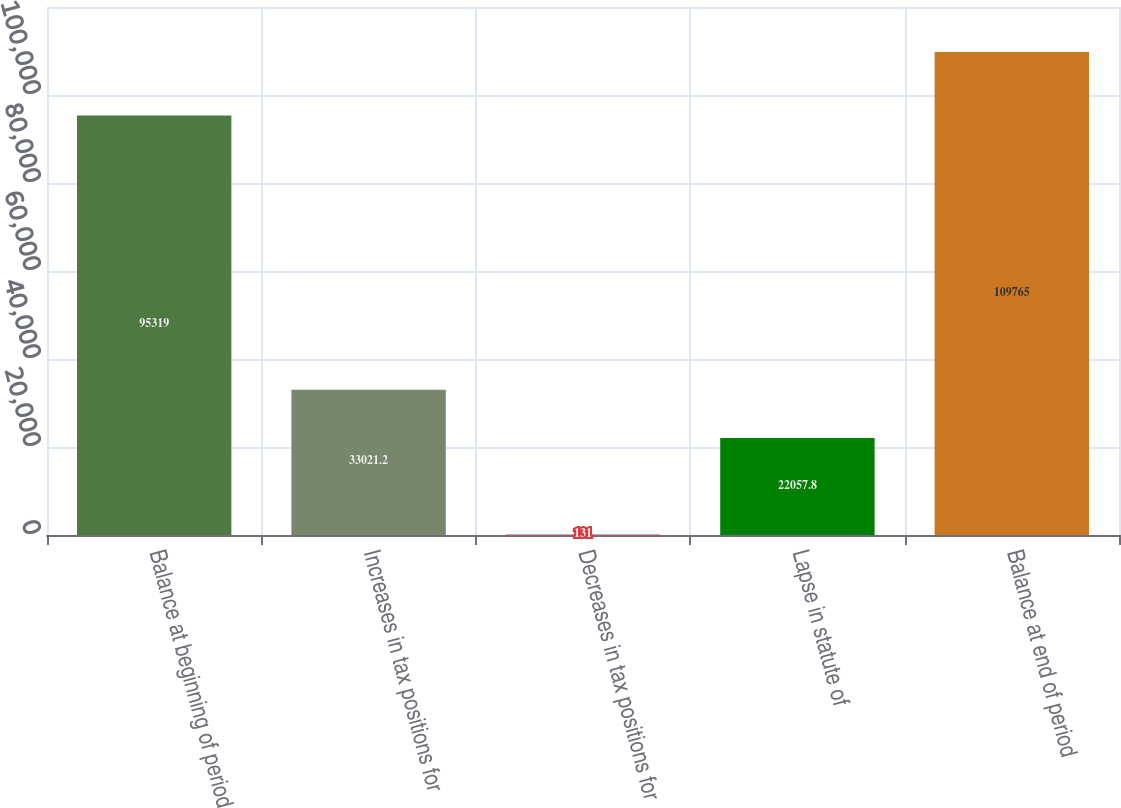Convert chart to OTSL. <chart><loc_0><loc_0><loc_500><loc_500><bar_chart><fcel>Balance at beginning of period<fcel>Increases in tax positions for<fcel>Decreases in tax positions for<fcel>Lapse in statute of<fcel>Balance at end of period<nl><fcel>95319<fcel>33021.2<fcel>131<fcel>22057.8<fcel>109765<nl></chart> 